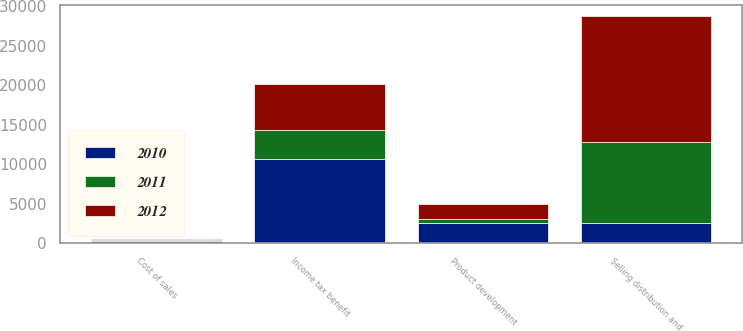Convert chart to OTSL. <chart><loc_0><loc_0><loc_500><loc_500><stacked_bar_chart><ecel><fcel>Cost of sales<fcel>Product development<fcel>Selling distribution and<fcel>Income tax benefit<nl><fcel>2012<fcel>146<fcel>1854<fcel>15874<fcel>5827<nl><fcel>2011<fcel>51<fcel>556<fcel>10296<fcel>3637<nl><fcel>2010<fcel>349<fcel>2576<fcel>2576<fcel>10658<nl></chart> 